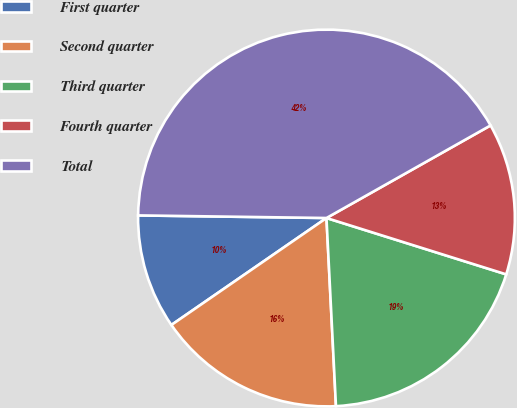<chart> <loc_0><loc_0><loc_500><loc_500><pie_chart><fcel>First quarter<fcel>Second quarter<fcel>Third quarter<fcel>Fourth quarter<fcel>Total<nl><fcel>9.83%<fcel>16.19%<fcel>19.36%<fcel>13.01%<fcel>41.6%<nl></chart> 